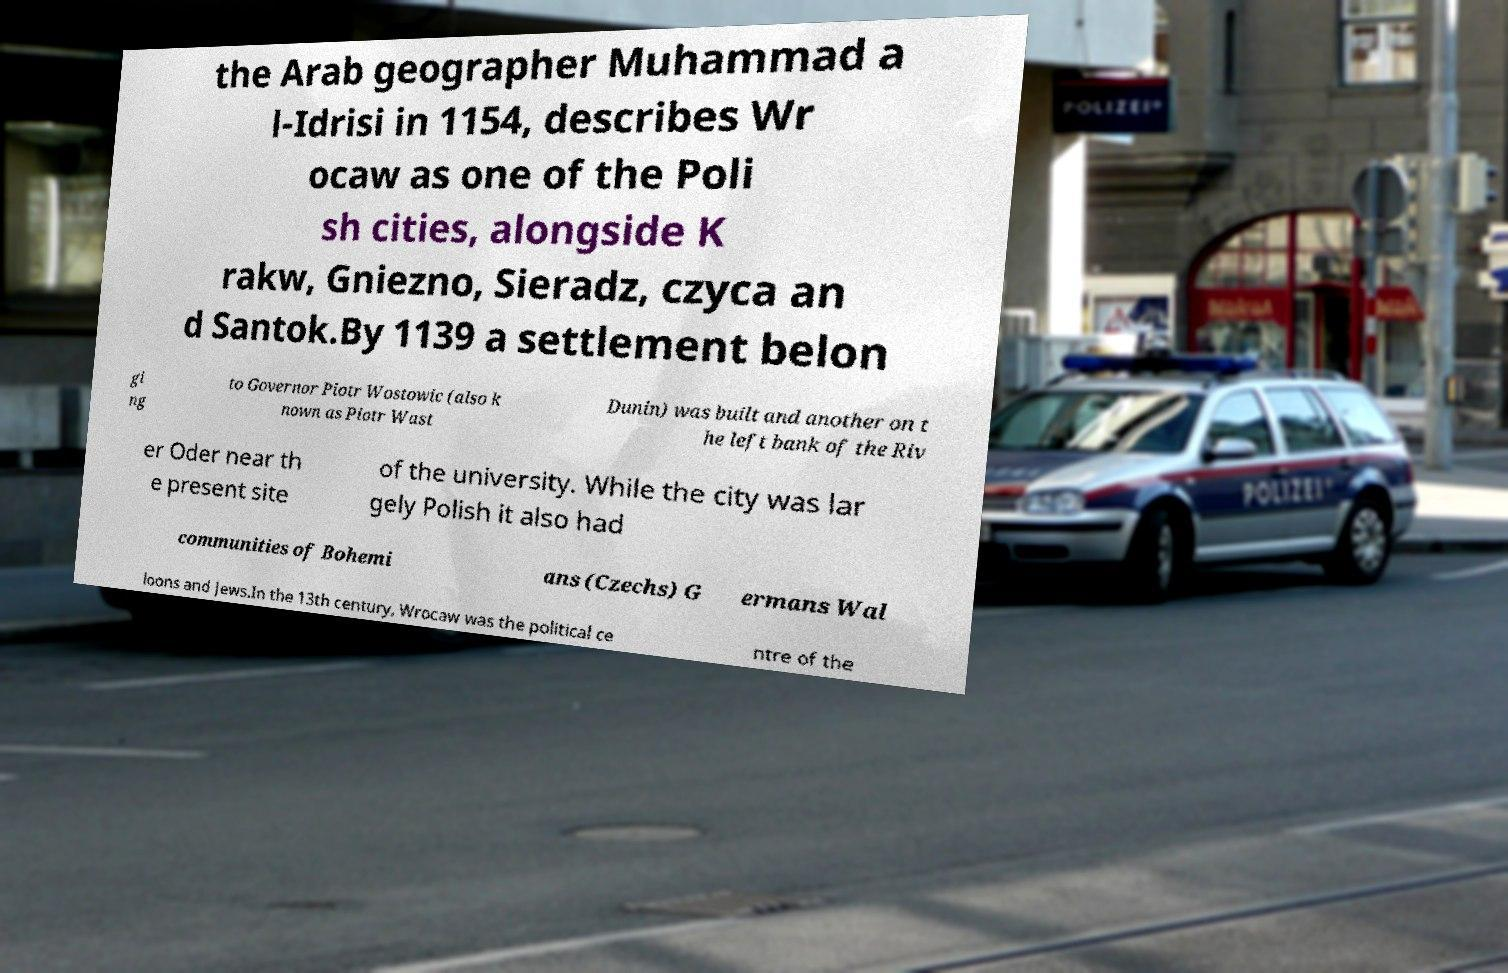Please read and relay the text visible in this image. What does it say? the Arab geographer Muhammad a l-Idrisi in 1154, describes Wr ocaw as one of the Poli sh cities, alongside K rakw, Gniezno, Sieradz, czyca an d Santok.By 1139 a settlement belon gi ng to Governor Piotr Wostowic (also k nown as Piotr Wast Dunin) was built and another on t he left bank of the Riv er Oder near th e present site of the university. While the city was lar gely Polish it also had communities of Bohemi ans (Czechs) G ermans Wal loons and Jews.In the 13th century, Wrocaw was the political ce ntre of the 